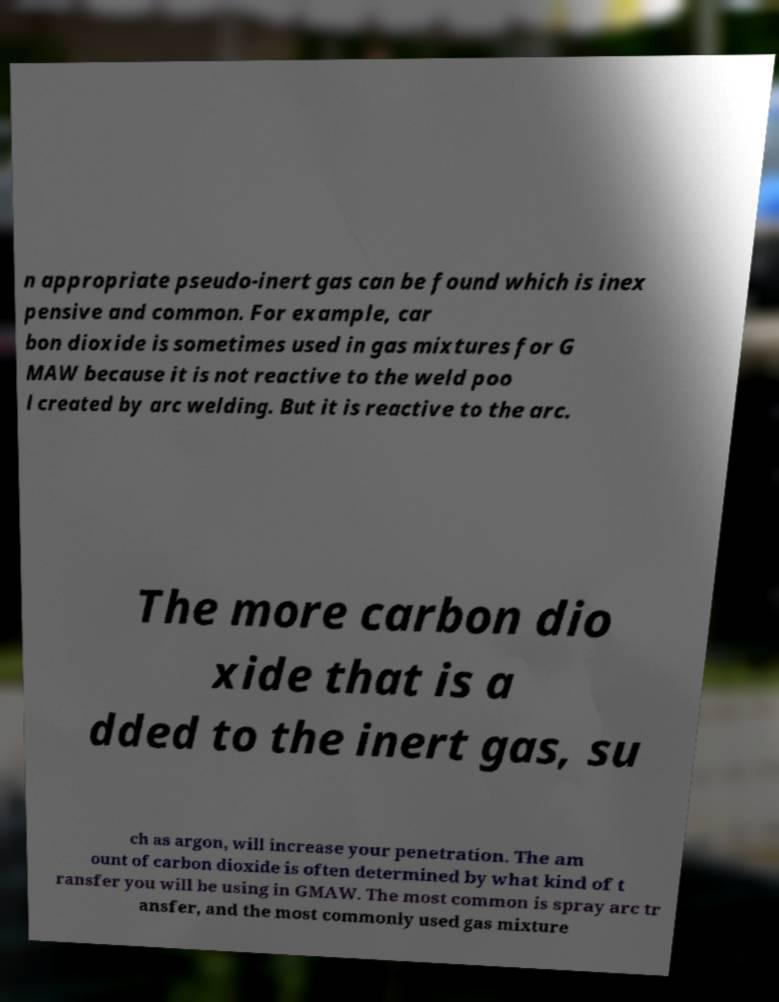For documentation purposes, I need the text within this image transcribed. Could you provide that? n appropriate pseudo-inert gas can be found which is inex pensive and common. For example, car bon dioxide is sometimes used in gas mixtures for G MAW because it is not reactive to the weld poo l created by arc welding. But it is reactive to the arc. The more carbon dio xide that is a dded to the inert gas, su ch as argon, will increase your penetration. The am ount of carbon dioxide is often determined by what kind of t ransfer you will be using in GMAW. The most common is spray arc tr ansfer, and the most commonly used gas mixture 